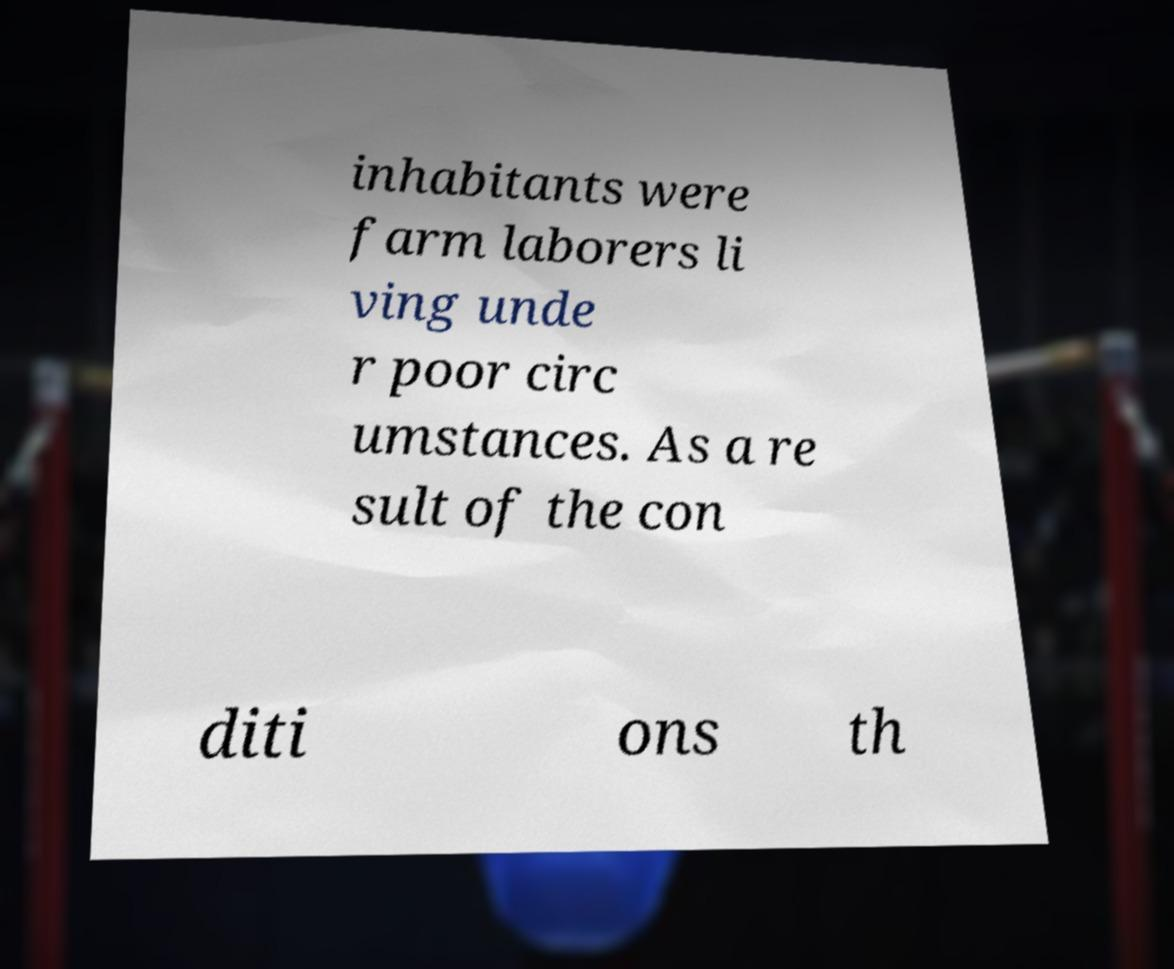Please read and relay the text visible in this image. What does it say? inhabitants were farm laborers li ving unde r poor circ umstances. As a re sult of the con diti ons th 